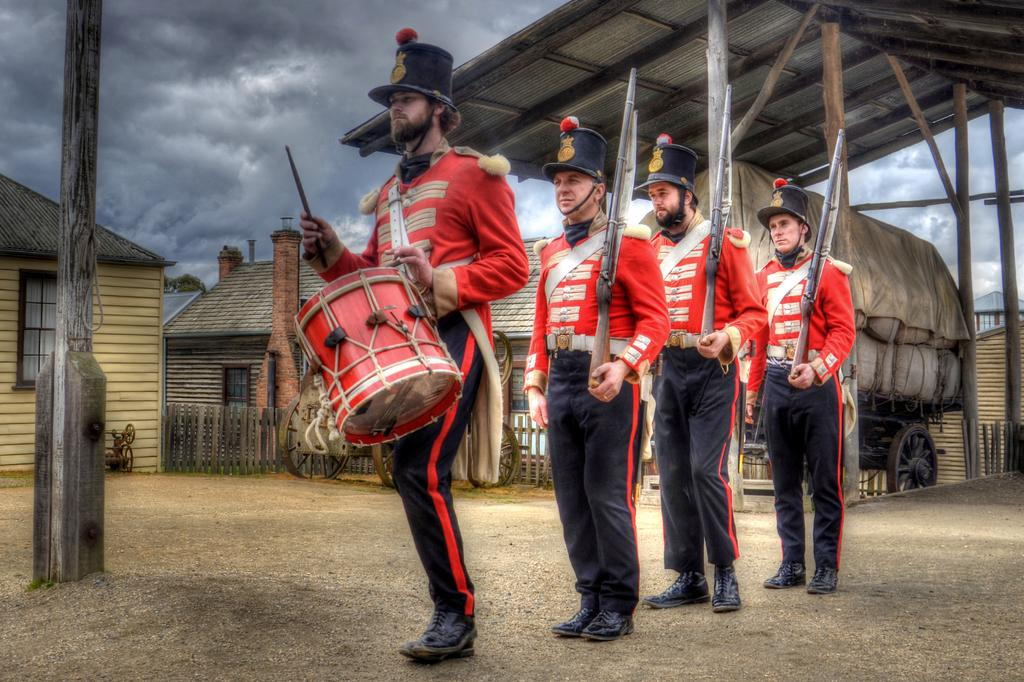How many people are in the image? There are four men in the image. What is the first person doing in the image? The first person is playing a drum. What are the other three people holding in the image? Each of the three people behind the drummer is holding a gun. What can be seen in the background of the image? There are houses, a vehicle, and a cloudy sky visible in the background. What type of attention is the drummer receiving from the people in the image? There is no indication in the image that the drummer is receiving any specific type of attention from the people. How does the selection of guns affect the overall mood of the image? The presence of guns in the image does not necessarily affect the overall mood, as there is no context provided for their use or purpose. 